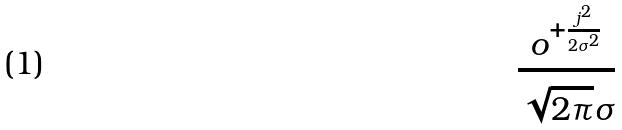Convert formula to latex. <formula><loc_0><loc_0><loc_500><loc_500>\frac { o ^ { + \frac { j ^ { 2 } } { 2 \sigma ^ { 2 } } } } { \sqrt { 2 \pi } \sigma }</formula> 